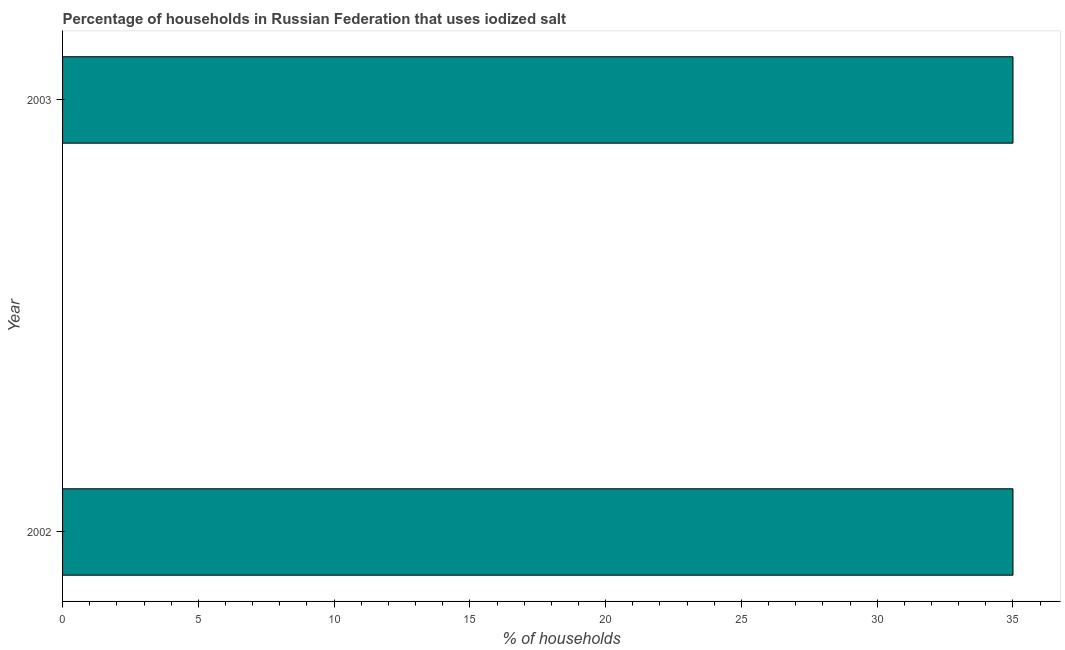Does the graph contain any zero values?
Provide a short and direct response. No. What is the title of the graph?
Provide a short and direct response. Percentage of households in Russian Federation that uses iodized salt. What is the label or title of the X-axis?
Give a very brief answer. % of households. Across all years, what is the maximum percentage of households where iodized salt is consumed?
Your answer should be compact. 35. In which year was the percentage of households where iodized salt is consumed maximum?
Your answer should be compact. 2002. In which year was the percentage of households where iodized salt is consumed minimum?
Your answer should be very brief. 2002. What is the median percentage of households where iodized salt is consumed?
Give a very brief answer. 35. In how many years, is the percentage of households where iodized salt is consumed greater than 16 %?
Offer a terse response. 2. What is the ratio of the percentage of households where iodized salt is consumed in 2002 to that in 2003?
Your response must be concise. 1. In how many years, is the percentage of households where iodized salt is consumed greater than the average percentage of households where iodized salt is consumed taken over all years?
Provide a short and direct response. 0. How many years are there in the graph?
Your answer should be very brief. 2. Are the values on the major ticks of X-axis written in scientific E-notation?
Your answer should be very brief. No. What is the % of households in 2002?
Offer a very short reply. 35. What is the % of households of 2003?
Your answer should be compact. 35. What is the ratio of the % of households in 2002 to that in 2003?
Ensure brevity in your answer.  1. 